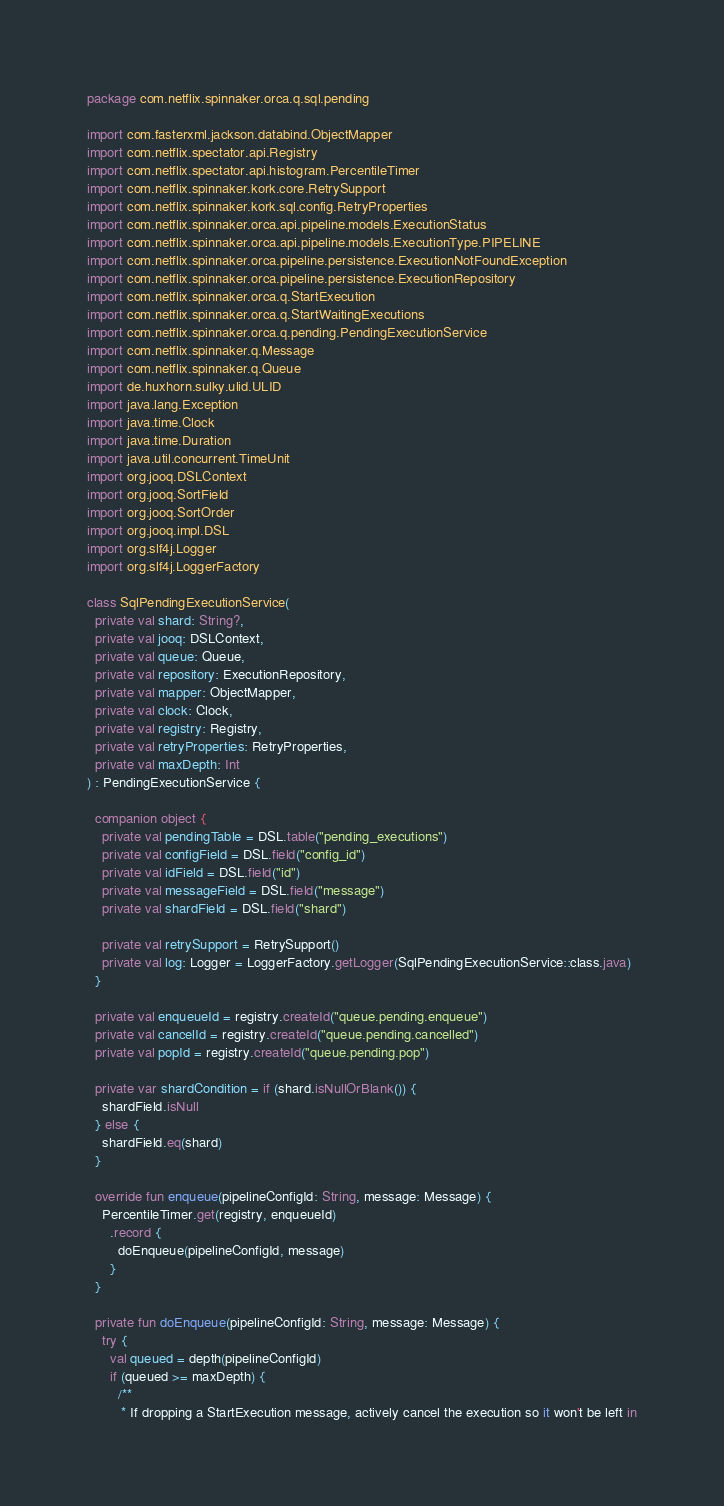Convert code to text. <code><loc_0><loc_0><loc_500><loc_500><_Kotlin_>package com.netflix.spinnaker.orca.q.sql.pending

import com.fasterxml.jackson.databind.ObjectMapper
import com.netflix.spectator.api.Registry
import com.netflix.spectator.api.histogram.PercentileTimer
import com.netflix.spinnaker.kork.core.RetrySupport
import com.netflix.spinnaker.kork.sql.config.RetryProperties
import com.netflix.spinnaker.orca.api.pipeline.models.ExecutionStatus
import com.netflix.spinnaker.orca.api.pipeline.models.ExecutionType.PIPELINE
import com.netflix.spinnaker.orca.pipeline.persistence.ExecutionNotFoundException
import com.netflix.spinnaker.orca.pipeline.persistence.ExecutionRepository
import com.netflix.spinnaker.orca.q.StartExecution
import com.netflix.spinnaker.orca.q.StartWaitingExecutions
import com.netflix.spinnaker.orca.q.pending.PendingExecutionService
import com.netflix.spinnaker.q.Message
import com.netflix.spinnaker.q.Queue
import de.huxhorn.sulky.ulid.ULID
import java.lang.Exception
import java.time.Clock
import java.time.Duration
import java.util.concurrent.TimeUnit
import org.jooq.DSLContext
import org.jooq.SortField
import org.jooq.SortOrder
import org.jooq.impl.DSL
import org.slf4j.Logger
import org.slf4j.LoggerFactory

class SqlPendingExecutionService(
  private val shard: String?,
  private val jooq: DSLContext,
  private val queue: Queue,
  private val repository: ExecutionRepository,
  private val mapper: ObjectMapper,
  private val clock: Clock,
  private val registry: Registry,
  private val retryProperties: RetryProperties,
  private val maxDepth: Int
) : PendingExecutionService {

  companion object {
    private val pendingTable = DSL.table("pending_executions")
    private val configField = DSL.field("config_id")
    private val idField = DSL.field("id")
    private val messageField = DSL.field("message")
    private val shardField = DSL.field("shard")

    private val retrySupport = RetrySupport()
    private val log: Logger = LoggerFactory.getLogger(SqlPendingExecutionService::class.java)
  }

  private val enqueueId = registry.createId("queue.pending.enqueue")
  private val cancelId = registry.createId("queue.pending.cancelled")
  private val popId = registry.createId("queue.pending.pop")

  private var shardCondition = if (shard.isNullOrBlank()) {
    shardField.isNull
  } else {
    shardField.eq(shard)
  }

  override fun enqueue(pipelineConfigId: String, message: Message) {
    PercentileTimer.get(registry, enqueueId)
      .record {
        doEnqueue(pipelineConfigId, message)
      }
  }

  private fun doEnqueue(pipelineConfigId: String, message: Message) {
    try {
      val queued = depth(pipelineConfigId)
      if (queued >= maxDepth) {
        /**
         * If dropping a StartExecution message, actively cancel the execution so it won't be left in</code> 